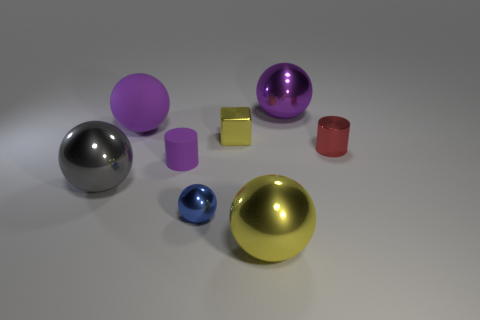Subtract all small spheres. How many spheres are left? 4 Subtract all blue spheres. How many spheres are left? 4 Subtract all cyan balls. Subtract all brown blocks. How many balls are left? 5 Add 1 small spheres. How many objects exist? 9 Subtract all cubes. How many objects are left? 7 Subtract 0 yellow cylinders. How many objects are left? 8 Subtract all tiny purple matte things. Subtract all large gray spheres. How many objects are left? 6 Add 7 tiny spheres. How many tiny spheres are left? 8 Add 8 big red balls. How many big red balls exist? 8 